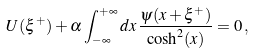<formula> <loc_0><loc_0><loc_500><loc_500>U ( \xi ^ { + } ) + \alpha \int ^ { + \infty } _ { - \infty } d x \, \frac { \psi ( x + \xi ^ { + } ) } { \cosh ^ { 2 } ( x ) } = 0 \, ,</formula> 